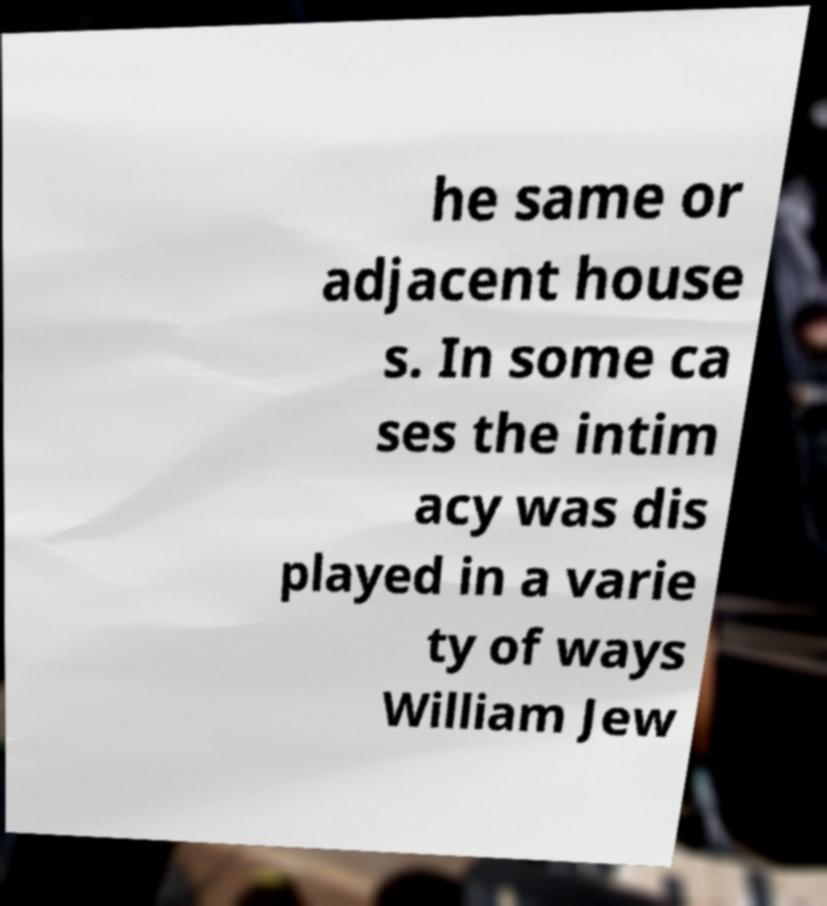I need the written content from this picture converted into text. Can you do that? he same or adjacent house s. In some ca ses the intim acy was dis played in a varie ty of ways William Jew 